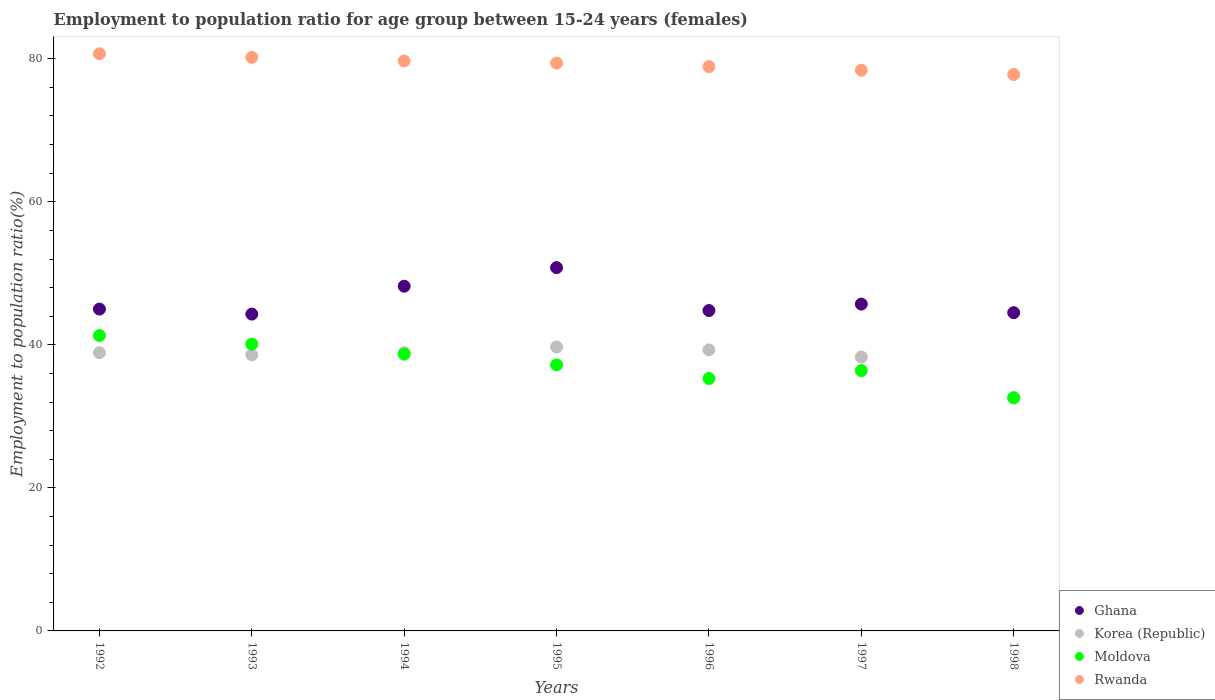How many different coloured dotlines are there?
Keep it short and to the point. 4. Is the number of dotlines equal to the number of legend labels?
Provide a succinct answer. Yes. What is the employment to population ratio in Rwanda in 1997?
Offer a terse response. 78.4. Across all years, what is the maximum employment to population ratio in Korea (Republic)?
Offer a very short reply. 39.7. Across all years, what is the minimum employment to population ratio in Ghana?
Make the answer very short. 44.3. In which year was the employment to population ratio in Moldova maximum?
Offer a very short reply. 1992. In which year was the employment to population ratio in Korea (Republic) minimum?
Provide a short and direct response. 1998. What is the total employment to population ratio in Rwanda in the graph?
Offer a very short reply. 555.1. What is the difference between the employment to population ratio in Rwanda in 1995 and that in 1998?
Make the answer very short. 1.6. What is the difference between the employment to population ratio in Korea (Republic) in 1993 and the employment to population ratio in Rwanda in 1995?
Provide a short and direct response. -40.8. What is the average employment to population ratio in Rwanda per year?
Provide a short and direct response. 79.3. In the year 1992, what is the difference between the employment to population ratio in Moldova and employment to population ratio in Rwanda?
Make the answer very short. -39.4. What is the ratio of the employment to population ratio in Korea (Republic) in 1992 to that in 1994?
Provide a short and direct response. 1. Is the employment to population ratio in Moldova in 1992 less than that in 1993?
Offer a terse response. No. What is the difference between the highest and the second highest employment to population ratio in Rwanda?
Offer a very short reply. 0.5. What is the difference between the highest and the lowest employment to population ratio in Korea (Republic)?
Provide a short and direct response. 7.1. In how many years, is the employment to population ratio in Moldova greater than the average employment to population ratio in Moldova taken over all years?
Provide a succinct answer. 3. Is the sum of the employment to population ratio in Ghana in 1993 and 1995 greater than the maximum employment to population ratio in Moldova across all years?
Provide a succinct answer. Yes. Is it the case that in every year, the sum of the employment to population ratio in Ghana and employment to population ratio in Korea (Republic)  is greater than the employment to population ratio in Moldova?
Give a very brief answer. Yes. Does the employment to population ratio in Korea (Republic) monotonically increase over the years?
Offer a very short reply. No. Is the employment to population ratio in Ghana strictly greater than the employment to population ratio in Moldova over the years?
Your response must be concise. Yes. How many dotlines are there?
Keep it short and to the point. 4. How many years are there in the graph?
Ensure brevity in your answer.  7. What is the difference between two consecutive major ticks on the Y-axis?
Your answer should be compact. 20. Are the values on the major ticks of Y-axis written in scientific E-notation?
Your response must be concise. No. How many legend labels are there?
Offer a very short reply. 4. How are the legend labels stacked?
Your response must be concise. Vertical. What is the title of the graph?
Your response must be concise. Employment to population ratio for age group between 15-24 years (females). What is the label or title of the X-axis?
Keep it short and to the point. Years. What is the Employment to population ratio(%) of Korea (Republic) in 1992?
Your response must be concise. 38.9. What is the Employment to population ratio(%) of Moldova in 1992?
Keep it short and to the point. 41.3. What is the Employment to population ratio(%) in Rwanda in 1992?
Give a very brief answer. 80.7. What is the Employment to population ratio(%) in Ghana in 1993?
Your response must be concise. 44.3. What is the Employment to population ratio(%) in Korea (Republic) in 1993?
Provide a short and direct response. 38.6. What is the Employment to population ratio(%) of Moldova in 1993?
Give a very brief answer. 40.1. What is the Employment to population ratio(%) in Rwanda in 1993?
Offer a terse response. 80.2. What is the Employment to population ratio(%) in Ghana in 1994?
Keep it short and to the point. 48.2. What is the Employment to population ratio(%) of Korea (Republic) in 1994?
Offer a very short reply. 38.9. What is the Employment to population ratio(%) of Moldova in 1994?
Offer a terse response. 38.7. What is the Employment to population ratio(%) in Rwanda in 1994?
Offer a terse response. 79.7. What is the Employment to population ratio(%) in Ghana in 1995?
Your response must be concise. 50.8. What is the Employment to population ratio(%) of Korea (Republic) in 1995?
Make the answer very short. 39.7. What is the Employment to population ratio(%) of Moldova in 1995?
Provide a succinct answer. 37.2. What is the Employment to population ratio(%) in Rwanda in 1995?
Give a very brief answer. 79.4. What is the Employment to population ratio(%) of Ghana in 1996?
Make the answer very short. 44.8. What is the Employment to population ratio(%) in Korea (Republic) in 1996?
Your response must be concise. 39.3. What is the Employment to population ratio(%) of Moldova in 1996?
Make the answer very short. 35.3. What is the Employment to population ratio(%) in Rwanda in 1996?
Offer a very short reply. 78.9. What is the Employment to population ratio(%) of Ghana in 1997?
Your response must be concise. 45.7. What is the Employment to population ratio(%) in Korea (Republic) in 1997?
Offer a very short reply. 38.3. What is the Employment to population ratio(%) in Moldova in 1997?
Provide a succinct answer. 36.4. What is the Employment to population ratio(%) in Rwanda in 1997?
Your answer should be compact. 78.4. What is the Employment to population ratio(%) of Ghana in 1998?
Give a very brief answer. 44.5. What is the Employment to population ratio(%) of Korea (Republic) in 1998?
Keep it short and to the point. 32.6. What is the Employment to population ratio(%) in Moldova in 1998?
Your response must be concise. 32.6. What is the Employment to population ratio(%) in Rwanda in 1998?
Give a very brief answer. 77.8. Across all years, what is the maximum Employment to population ratio(%) of Ghana?
Make the answer very short. 50.8. Across all years, what is the maximum Employment to population ratio(%) in Korea (Republic)?
Offer a very short reply. 39.7. Across all years, what is the maximum Employment to population ratio(%) of Moldova?
Offer a very short reply. 41.3. Across all years, what is the maximum Employment to population ratio(%) in Rwanda?
Ensure brevity in your answer.  80.7. Across all years, what is the minimum Employment to population ratio(%) of Ghana?
Your answer should be very brief. 44.3. Across all years, what is the minimum Employment to population ratio(%) in Korea (Republic)?
Offer a very short reply. 32.6. Across all years, what is the minimum Employment to population ratio(%) in Moldova?
Give a very brief answer. 32.6. Across all years, what is the minimum Employment to population ratio(%) of Rwanda?
Provide a short and direct response. 77.8. What is the total Employment to population ratio(%) in Ghana in the graph?
Make the answer very short. 323.3. What is the total Employment to population ratio(%) in Korea (Republic) in the graph?
Offer a terse response. 266.3. What is the total Employment to population ratio(%) in Moldova in the graph?
Your answer should be very brief. 261.6. What is the total Employment to population ratio(%) in Rwanda in the graph?
Keep it short and to the point. 555.1. What is the difference between the Employment to population ratio(%) of Rwanda in 1992 and that in 1993?
Give a very brief answer. 0.5. What is the difference between the Employment to population ratio(%) in Ghana in 1992 and that in 1994?
Make the answer very short. -3.2. What is the difference between the Employment to population ratio(%) of Rwanda in 1992 and that in 1994?
Your answer should be compact. 1. What is the difference between the Employment to population ratio(%) in Korea (Republic) in 1992 and that in 1995?
Your response must be concise. -0.8. What is the difference between the Employment to population ratio(%) of Ghana in 1992 and that in 1996?
Keep it short and to the point. 0.2. What is the difference between the Employment to population ratio(%) of Korea (Republic) in 1992 and that in 1996?
Your answer should be compact. -0.4. What is the difference between the Employment to population ratio(%) of Moldova in 1992 and that in 1997?
Your answer should be compact. 4.9. What is the difference between the Employment to population ratio(%) of Rwanda in 1992 and that in 1997?
Offer a very short reply. 2.3. What is the difference between the Employment to population ratio(%) of Korea (Republic) in 1992 and that in 1998?
Offer a very short reply. 6.3. What is the difference between the Employment to population ratio(%) of Rwanda in 1992 and that in 1998?
Provide a succinct answer. 2.9. What is the difference between the Employment to population ratio(%) of Ghana in 1993 and that in 1994?
Give a very brief answer. -3.9. What is the difference between the Employment to population ratio(%) of Moldova in 1993 and that in 1994?
Ensure brevity in your answer.  1.4. What is the difference between the Employment to population ratio(%) of Rwanda in 1993 and that in 1994?
Offer a very short reply. 0.5. What is the difference between the Employment to population ratio(%) of Korea (Republic) in 1993 and that in 1995?
Make the answer very short. -1.1. What is the difference between the Employment to population ratio(%) of Moldova in 1993 and that in 1995?
Offer a very short reply. 2.9. What is the difference between the Employment to population ratio(%) in Rwanda in 1993 and that in 1995?
Offer a very short reply. 0.8. What is the difference between the Employment to population ratio(%) in Moldova in 1993 and that in 1996?
Give a very brief answer. 4.8. What is the difference between the Employment to population ratio(%) of Moldova in 1993 and that in 1997?
Offer a very short reply. 3.7. What is the difference between the Employment to population ratio(%) of Rwanda in 1993 and that in 1997?
Make the answer very short. 1.8. What is the difference between the Employment to population ratio(%) in Ghana in 1993 and that in 1998?
Ensure brevity in your answer.  -0.2. What is the difference between the Employment to population ratio(%) of Rwanda in 1993 and that in 1998?
Offer a very short reply. 2.4. What is the difference between the Employment to population ratio(%) in Ghana in 1994 and that in 1995?
Give a very brief answer. -2.6. What is the difference between the Employment to population ratio(%) of Korea (Republic) in 1994 and that in 1995?
Offer a terse response. -0.8. What is the difference between the Employment to population ratio(%) in Rwanda in 1994 and that in 1995?
Ensure brevity in your answer.  0.3. What is the difference between the Employment to population ratio(%) of Ghana in 1994 and that in 1996?
Provide a succinct answer. 3.4. What is the difference between the Employment to population ratio(%) in Korea (Republic) in 1994 and that in 1996?
Provide a short and direct response. -0.4. What is the difference between the Employment to population ratio(%) in Moldova in 1994 and that in 1996?
Offer a terse response. 3.4. What is the difference between the Employment to population ratio(%) of Ghana in 1994 and that in 1997?
Give a very brief answer. 2.5. What is the difference between the Employment to population ratio(%) in Moldova in 1994 and that in 1997?
Provide a short and direct response. 2.3. What is the difference between the Employment to population ratio(%) of Korea (Republic) in 1994 and that in 1998?
Provide a short and direct response. 6.3. What is the difference between the Employment to population ratio(%) in Rwanda in 1994 and that in 1998?
Make the answer very short. 1.9. What is the difference between the Employment to population ratio(%) in Ghana in 1995 and that in 1996?
Keep it short and to the point. 6. What is the difference between the Employment to population ratio(%) of Korea (Republic) in 1995 and that in 1996?
Provide a succinct answer. 0.4. What is the difference between the Employment to population ratio(%) of Moldova in 1995 and that in 1996?
Your answer should be compact. 1.9. What is the difference between the Employment to population ratio(%) in Korea (Republic) in 1995 and that in 1997?
Offer a terse response. 1.4. What is the difference between the Employment to population ratio(%) in Moldova in 1995 and that in 1997?
Make the answer very short. 0.8. What is the difference between the Employment to population ratio(%) in Moldova in 1995 and that in 1998?
Your answer should be compact. 4.6. What is the difference between the Employment to population ratio(%) of Korea (Republic) in 1996 and that in 1997?
Ensure brevity in your answer.  1. What is the difference between the Employment to population ratio(%) in Rwanda in 1996 and that in 1997?
Offer a terse response. 0.5. What is the difference between the Employment to population ratio(%) in Moldova in 1996 and that in 1998?
Provide a succinct answer. 2.7. What is the difference between the Employment to population ratio(%) of Rwanda in 1996 and that in 1998?
Provide a short and direct response. 1.1. What is the difference between the Employment to population ratio(%) in Ghana in 1997 and that in 1998?
Make the answer very short. 1.2. What is the difference between the Employment to population ratio(%) of Korea (Republic) in 1997 and that in 1998?
Your answer should be very brief. 5.7. What is the difference between the Employment to population ratio(%) in Rwanda in 1997 and that in 1998?
Your answer should be very brief. 0.6. What is the difference between the Employment to population ratio(%) of Ghana in 1992 and the Employment to population ratio(%) of Moldova in 1993?
Give a very brief answer. 4.9. What is the difference between the Employment to population ratio(%) of Ghana in 1992 and the Employment to population ratio(%) of Rwanda in 1993?
Make the answer very short. -35.2. What is the difference between the Employment to population ratio(%) of Korea (Republic) in 1992 and the Employment to population ratio(%) of Rwanda in 1993?
Your answer should be very brief. -41.3. What is the difference between the Employment to population ratio(%) in Moldova in 1992 and the Employment to population ratio(%) in Rwanda in 1993?
Ensure brevity in your answer.  -38.9. What is the difference between the Employment to population ratio(%) in Ghana in 1992 and the Employment to population ratio(%) in Korea (Republic) in 1994?
Offer a very short reply. 6.1. What is the difference between the Employment to population ratio(%) of Ghana in 1992 and the Employment to population ratio(%) of Moldova in 1994?
Your answer should be compact. 6.3. What is the difference between the Employment to population ratio(%) in Ghana in 1992 and the Employment to population ratio(%) in Rwanda in 1994?
Keep it short and to the point. -34.7. What is the difference between the Employment to population ratio(%) of Korea (Republic) in 1992 and the Employment to population ratio(%) of Moldova in 1994?
Your response must be concise. 0.2. What is the difference between the Employment to population ratio(%) of Korea (Republic) in 1992 and the Employment to population ratio(%) of Rwanda in 1994?
Provide a succinct answer. -40.8. What is the difference between the Employment to population ratio(%) of Moldova in 1992 and the Employment to population ratio(%) of Rwanda in 1994?
Make the answer very short. -38.4. What is the difference between the Employment to population ratio(%) in Ghana in 1992 and the Employment to population ratio(%) in Korea (Republic) in 1995?
Give a very brief answer. 5.3. What is the difference between the Employment to population ratio(%) of Ghana in 1992 and the Employment to population ratio(%) of Rwanda in 1995?
Provide a succinct answer. -34.4. What is the difference between the Employment to population ratio(%) in Korea (Republic) in 1992 and the Employment to population ratio(%) in Rwanda in 1995?
Your answer should be very brief. -40.5. What is the difference between the Employment to population ratio(%) of Moldova in 1992 and the Employment to population ratio(%) of Rwanda in 1995?
Provide a succinct answer. -38.1. What is the difference between the Employment to population ratio(%) in Ghana in 1992 and the Employment to population ratio(%) in Korea (Republic) in 1996?
Offer a terse response. 5.7. What is the difference between the Employment to population ratio(%) in Ghana in 1992 and the Employment to population ratio(%) in Rwanda in 1996?
Your answer should be compact. -33.9. What is the difference between the Employment to population ratio(%) of Korea (Republic) in 1992 and the Employment to population ratio(%) of Moldova in 1996?
Your answer should be compact. 3.6. What is the difference between the Employment to population ratio(%) in Korea (Republic) in 1992 and the Employment to population ratio(%) in Rwanda in 1996?
Provide a succinct answer. -40. What is the difference between the Employment to population ratio(%) of Moldova in 1992 and the Employment to population ratio(%) of Rwanda in 1996?
Your response must be concise. -37.6. What is the difference between the Employment to population ratio(%) of Ghana in 1992 and the Employment to population ratio(%) of Korea (Republic) in 1997?
Provide a succinct answer. 6.7. What is the difference between the Employment to population ratio(%) in Ghana in 1992 and the Employment to population ratio(%) in Moldova in 1997?
Your answer should be compact. 8.6. What is the difference between the Employment to population ratio(%) in Ghana in 1992 and the Employment to population ratio(%) in Rwanda in 1997?
Your answer should be compact. -33.4. What is the difference between the Employment to population ratio(%) in Korea (Republic) in 1992 and the Employment to population ratio(%) in Moldova in 1997?
Provide a short and direct response. 2.5. What is the difference between the Employment to population ratio(%) in Korea (Republic) in 1992 and the Employment to population ratio(%) in Rwanda in 1997?
Keep it short and to the point. -39.5. What is the difference between the Employment to population ratio(%) of Moldova in 1992 and the Employment to population ratio(%) of Rwanda in 1997?
Offer a terse response. -37.1. What is the difference between the Employment to population ratio(%) of Ghana in 1992 and the Employment to population ratio(%) of Korea (Republic) in 1998?
Ensure brevity in your answer.  12.4. What is the difference between the Employment to population ratio(%) in Ghana in 1992 and the Employment to population ratio(%) in Moldova in 1998?
Offer a terse response. 12.4. What is the difference between the Employment to population ratio(%) of Ghana in 1992 and the Employment to population ratio(%) of Rwanda in 1998?
Make the answer very short. -32.8. What is the difference between the Employment to population ratio(%) of Korea (Republic) in 1992 and the Employment to population ratio(%) of Rwanda in 1998?
Give a very brief answer. -38.9. What is the difference between the Employment to population ratio(%) of Moldova in 1992 and the Employment to population ratio(%) of Rwanda in 1998?
Your answer should be very brief. -36.5. What is the difference between the Employment to population ratio(%) in Ghana in 1993 and the Employment to population ratio(%) in Moldova in 1994?
Provide a short and direct response. 5.6. What is the difference between the Employment to population ratio(%) of Ghana in 1993 and the Employment to population ratio(%) of Rwanda in 1994?
Keep it short and to the point. -35.4. What is the difference between the Employment to population ratio(%) in Korea (Republic) in 1993 and the Employment to population ratio(%) in Moldova in 1994?
Offer a terse response. -0.1. What is the difference between the Employment to population ratio(%) of Korea (Republic) in 1993 and the Employment to population ratio(%) of Rwanda in 1994?
Ensure brevity in your answer.  -41.1. What is the difference between the Employment to population ratio(%) of Moldova in 1993 and the Employment to population ratio(%) of Rwanda in 1994?
Make the answer very short. -39.6. What is the difference between the Employment to population ratio(%) of Ghana in 1993 and the Employment to population ratio(%) of Korea (Republic) in 1995?
Give a very brief answer. 4.6. What is the difference between the Employment to population ratio(%) in Ghana in 1993 and the Employment to population ratio(%) in Rwanda in 1995?
Ensure brevity in your answer.  -35.1. What is the difference between the Employment to population ratio(%) of Korea (Republic) in 1993 and the Employment to population ratio(%) of Rwanda in 1995?
Offer a very short reply. -40.8. What is the difference between the Employment to population ratio(%) of Moldova in 1993 and the Employment to population ratio(%) of Rwanda in 1995?
Provide a short and direct response. -39.3. What is the difference between the Employment to population ratio(%) in Ghana in 1993 and the Employment to population ratio(%) in Moldova in 1996?
Your answer should be compact. 9. What is the difference between the Employment to population ratio(%) in Ghana in 1993 and the Employment to population ratio(%) in Rwanda in 1996?
Offer a very short reply. -34.6. What is the difference between the Employment to population ratio(%) in Korea (Republic) in 1993 and the Employment to population ratio(%) in Rwanda in 1996?
Make the answer very short. -40.3. What is the difference between the Employment to population ratio(%) of Moldova in 1993 and the Employment to population ratio(%) of Rwanda in 1996?
Provide a short and direct response. -38.8. What is the difference between the Employment to population ratio(%) in Ghana in 1993 and the Employment to population ratio(%) in Korea (Republic) in 1997?
Keep it short and to the point. 6. What is the difference between the Employment to population ratio(%) in Ghana in 1993 and the Employment to population ratio(%) in Rwanda in 1997?
Make the answer very short. -34.1. What is the difference between the Employment to population ratio(%) of Korea (Republic) in 1993 and the Employment to population ratio(%) of Moldova in 1997?
Provide a succinct answer. 2.2. What is the difference between the Employment to population ratio(%) of Korea (Republic) in 1993 and the Employment to population ratio(%) of Rwanda in 1997?
Your answer should be compact. -39.8. What is the difference between the Employment to population ratio(%) in Moldova in 1993 and the Employment to population ratio(%) in Rwanda in 1997?
Ensure brevity in your answer.  -38.3. What is the difference between the Employment to population ratio(%) of Ghana in 1993 and the Employment to population ratio(%) of Korea (Republic) in 1998?
Keep it short and to the point. 11.7. What is the difference between the Employment to population ratio(%) of Ghana in 1993 and the Employment to population ratio(%) of Moldova in 1998?
Give a very brief answer. 11.7. What is the difference between the Employment to population ratio(%) in Ghana in 1993 and the Employment to population ratio(%) in Rwanda in 1998?
Keep it short and to the point. -33.5. What is the difference between the Employment to population ratio(%) of Korea (Republic) in 1993 and the Employment to population ratio(%) of Rwanda in 1998?
Offer a very short reply. -39.2. What is the difference between the Employment to population ratio(%) in Moldova in 1993 and the Employment to population ratio(%) in Rwanda in 1998?
Keep it short and to the point. -37.7. What is the difference between the Employment to population ratio(%) of Ghana in 1994 and the Employment to population ratio(%) of Korea (Republic) in 1995?
Offer a terse response. 8.5. What is the difference between the Employment to population ratio(%) of Ghana in 1994 and the Employment to population ratio(%) of Moldova in 1995?
Offer a terse response. 11. What is the difference between the Employment to population ratio(%) of Ghana in 1994 and the Employment to population ratio(%) of Rwanda in 1995?
Give a very brief answer. -31.2. What is the difference between the Employment to population ratio(%) in Korea (Republic) in 1994 and the Employment to population ratio(%) in Moldova in 1995?
Your answer should be compact. 1.7. What is the difference between the Employment to population ratio(%) of Korea (Republic) in 1994 and the Employment to population ratio(%) of Rwanda in 1995?
Ensure brevity in your answer.  -40.5. What is the difference between the Employment to population ratio(%) in Moldova in 1994 and the Employment to population ratio(%) in Rwanda in 1995?
Give a very brief answer. -40.7. What is the difference between the Employment to population ratio(%) of Ghana in 1994 and the Employment to population ratio(%) of Korea (Republic) in 1996?
Make the answer very short. 8.9. What is the difference between the Employment to population ratio(%) in Ghana in 1994 and the Employment to population ratio(%) in Moldova in 1996?
Your response must be concise. 12.9. What is the difference between the Employment to population ratio(%) of Ghana in 1994 and the Employment to population ratio(%) of Rwanda in 1996?
Your response must be concise. -30.7. What is the difference between the Employment to population ratio(%) of Korea (Republic) in 1994 and the Employment to population ratio(%) of Moldova in 1996?
Your answer should be compact. 3.6. What is the difference between the Employment to population ratio(%) of Korea (Republic) in 1994 and the Employment to population ratio(%) of Rwanda in 1996?
Give a very brief answer. -40. What is the difference between the Employment to population ratio(%) in Moldova in 1994 and the Employment to population ratio(%) in Rwanda in 1996?
Your answer should be very brief. -40.2. What is the difference between the Employment to population ratio(%) of Ghana in 1994 and the Employment to population ratio(%) of Moldova in 1997?
Make the answer very short. 11.8. What is the difference between the Employment to population ratio(%) of Ghana in 1994 and the Employment to population ratio(%) of Rwanda in 1997?
Provide a succinct answer. -30.2. What is the difference between the Employment to population ratio(%) in Korea (Republic) in 1994 and the Employment to population ratio(%) in Rwanda in 1997?
Keep it short and to the point. -39.5. What is the difference between the Employment to population ratio(%) in Moldova in 1994 and the Employment to population ratio(%) in Rwanda in 1997?
Your response must be concise. -39.7. What is the difference between the Employment to population ratio(%) of Ghana in 1994 and the Employment to population ratio(%) of Korea (Republic) in 1998?
Your answer should be very brief. 15.6. What is the difference between the Employment to population ratio(%) of Ghana in 1994 and the Employment to population ratio(%) of Moldova in 1998?
Offer a very short reply. 15.6. What is the difference between the Employment to population ratio(%) of Ghana in 1994 and the Employment to population ratio(%) of Rwanda in 1998?
Offer a very short reply. -29.6. What is the difference between the Employment to population ratio(%) in Korea (Republic) in 1994 and the Employment to population ratio(%) in Rwanda in 1998?
Provide a succinct answer. -38.9. What is the difference between the Employment to population ratio(%) in Moldova in 1994 and the Employment to population ratio(%) in Rwanda in 1998?
Offer a terse response. -39.1. What is the difference between the Employment to population ratio(%) of Ghana in 1995 and the Employment to population ratio(%) of Rwanda in 1996?
Provide a succinct answer. -28.1. What is the difference between the Employment to population ratio(%) of Korea (Republic) in 1995 and the Employment to population ratio(%) of Rwanda in 1996?
Give a very brief answer. -39.2. What is the difference between the Employment to population ratio(%) in Moldova in 1995 and the Employment to population ratio(%) in Rwanda in 1996?
Make the answer very short. -41.7. What is the difference between the Employment to population ratio(%) of Ghana in 1995 and the Employment to population ratio(%) of Rwanda in 1997?
Provide a succinct answer. -27.6. What is the difference between the Employment to population ratio(%) of Korea (Republic) in 1995 and the Employment to population ratio(%) of Moldova in 1997?
Offer a terse response. 3.3. What is the difference between the Employment to population ratio(%) in Korea (Republic) in 1995 and the Employment to population ratio(%) in Rwanda in 1997?
Your answer should be compact. -38.7. What is the difference between the Employment to population ratio(%) of Moldova in 1995 and the Employment to population ratio(%) of Rwanda in 1997?
Offer a very short reply. -41.2. What is the difference between the Employment to population ratio(%) in Ghana in 1995 and the Employment to population ratio(%) in Moldova in 1998?
Your answer should be compact. 18.2. What is the difference between the Employment to population ratio(%) in Korea (Republic) in 1995 and the Employment to population ratio(%) in Moldova in 1998?
Your response must be concise. 7.1. What is the difference between the Employment to population ratio(%) of Korea (Republic) in 1995 and the Employment to population ratio(%) of Rwanda in 1998?
Offer a terse response. -38.1. What is the difference between the Employment to population ratio(%) in Moldova in 1995 and the Employment to population ratio(%) in Rwanda in 1998?
Provide a short and direct response. -40.6. What is the difference between the Employment to population ratio(%) of Ghana in 1996 and the Employment to population ratio(%) of Rwanda in 1997?
Keep it short and to the point. -33.6. What is the difference between the Employment to population ratio(%) in Korea (Republic) in 1996 and the Employment to population ratio(%) in Moldova in 1997?
Give a very brief answer. 2.9. What is the difference between the Employment to population ratio(%) in Korea (Republic) in 1996 and the Employment to population ratio(%) in Rwanda in 1997?
Provide a short and direct response. -39.1. What is the difference between the Employment to population ratio(%) of Moldova in 1996 and the Employment to population ratio(%) of Rwanda in 1997?
Your response must be concise. -43.1. What is the difference between the Employment to population ratio(%) of Ghana in 1996 and the Employment to population ratio(%) of Moldova in 1998?
Your answer should be compact. 12.2. What is the difference between the Employment to population ratio(%) of Ghana in 1996 and the Employment to population ratio(%) of Rwanda in 1998?
Ensure brevity in your answer.  -33. What is the difference between the Employment to population ratio(%) of Korea (Republic) in 1996 and the Employment to population ratio(%) of Rwanda in 1998?
Offer a very short reply. -38.5. What is the difference between the Employment to population ratio(%) in Moldova in 1996 and the Employment to population ratio(%) in Rwanda in 1998?
Give a very brief answer. -42.5. What is the difference between the Employment to population ratio(%) of Ghana in 1997 and the Employment to population ratio(%) of Korea (Republic) in 1998?
Provide a short and direct response. 13.1. What is the difference between the Employment to population ratio(%) in Ghana in 1997 and the Employment to population ratio(%) in Rwanda in 1998?
Provide a short and direct response. -32.1. What is the difference between the Employment to population ratio(%) of Korea (Republic) in 1997 and the Employment to population ratio(%) of Rwanda in 1998?
Your response must be concise. -39.5. What is the difference between the Employment to population ratio(%) in Moldova in 1997 and the Employment to population ratio(%) in Rwanda in 1998?
Offer a terse response. -41.4. What is the average Employment to population ratio(%) of Ghana per year?
Your answer should be very brief. 46.19. What is the average Employment to population ratio(%) of Korea (Republic) per year?
Keep it short and to the point. 38.04. What is the average Employment to population ratio(%) in Moldova per year?
Your answer should be compact. 37.37. What is the average Employment to population ratio(%) in Rwanda per year?
Your answer should be compact. 79.3. In the year 1992, what is the difference between the Employment to population ratio(%) of Ghana and Employment to population ratio(%) of Rwanda?
Ensure brevity in your answer.  -35.7. In the year 1992, what is the difference between the Employment to population ratio(%) in Korea (Republic) and Employment to population ratio(%) in Rwanda?
Your answer should be very brief. -41.8. In the year 1992, what is the difference between the Employment to population ratio(%) in Moldova and Employment to population ratio(%) in Rwanda?
Offer a terse response. -39.4. In the year 1993, what is the difference between the Employment to population ratio(%) in Ghana and Employment to population ratio(%) in Korea (Republic)?
Your response must be concise. 5.7. In the year 1993, what is the difference between the Employment to population ratio(%) of Ghana and Employment to population ratio(%) of Rwanda?
Make the answer very short. -35.9. In the year 1993, what is the difference between the Employment to population ratio(%) of Korea (Republic) and Employment to population ratio(%) of Rwanda?
Offer a terse response. -41.6. In the year 1993, what is the difference between the Employment to population ratio(%) of Moldova and Employment to population ratio(%) of Rwanda?
Make the answer very short. -40.1. In the year 1994, what is the difference between the Employment to population ratio(%) in Ghana and Employment to population ratio(%) in Rwanda?
Offer a very short reply. -31.5. In the year 1994, what is the difference between the Employment to population ratio(%) in Korea (Republic) and Employment to population ratio(%) in Rwanda?
Offer a very short reply. -40.8. In the year 1994, what is the difference between the Employment to population ratio(%) in Moldova and Employment to population ratio(%) in Rwanda?
Provide a short and direct response. -41. In the year 1995, what is the difference between the Employment to population ratio(%) in Ghana and Employment to population ratio(%) in Korea (Republic)?
Offer a very short reply. 11.1. In the year 1995, what is the difference between the Employment to population ratio(%) of Ghana and Employment to population ratio(%) of Rwanda?
Ensure brevity in your answer.  -28.6. In the year 1995, what is the difference between the Employment to population ratio(%) in Korea (Republic) and Employment to population ratio(%) in Rwanda?
Ensure brevity in your answer.  -39.7. In the year 1995, what is the difference between the Employment to population ratio(%) in Moldova and Employment to population ratio(%) in Rwanda?
Keep it short and to the point. -42.2. In the year 1996, what is the difference between the Employment to population ratio(%) in Ghana and Employment to population ratio(%) in Rwanda?
Ensure brevity in your answer.  -34.1. In the year 1996, what is the difference between the Employment to population ratio(%) in Korea (Republic) and Employment to population ratio(%) in Rwanda?
Keep it short and to the point. -39.6. In the year 1996, what is the difference between the Employment to population ratio(%) in Moldova and Employment to population ratio(%) in Rwanda?
Keep it short and to the point. -43.6. In the year 1997, what is the difference between the Employment to population ratio(%) in Ghana and Employment to population ratio(%) in Korea (Republic)?
Offer a very short reply. 7.4. In the year 1997, what is the difference between the Employment to population ratio(%) of Ghana and Employment to population ratio(%) of Moldova?
Your answer should be very brief. 9.3. In the year 1997, what is the difference between the Employment to population ratio(%) of Ghana and Employment to population ratio(%) of Rwanda?
Your answer should be compact. -32.7. In the year 1997, what is the difference between the Employment to population ratio(%) of Korea (Republic) and Employment to population ratio(%) of Moldova?
Your response must be concise. 1.9. In the year 1997, what is the difference between the Employment to population ratio(%) in Korea (Republic) and Employment to population ratio(%) in Rwanda?
Ensure brevity in your answer.  -40.1. In the year 1997, what is the difference between the Employment to population ratio(%) in Moldova and Employment to population ratio(%) in Rwanda?
Provide a succinct answer. -42. In the year 1998, what is the difference between the Employment to population ratio(%) of Ghana and Employment to population ratio(%) of Moldova?
Give a very brief answer. 11.9. In the year 1998, what is the difference between the Employment to population ratio(%) in Ghana and Employment to population ratio(%) in Rwanda?
Ensure brevity in your answer.  -33.3. In the year 1998, what is the difference between the Employment to population ratio(%) in Korea (Republic) and Employment to population ratio(%) in Moldova?
Make the answer very short. 0. In the year 1998, what is the difference between the Employment to population ratio(%) in Korea (Republic) and Employment to population ratio(%) in Rwanda?
Your response must be concise. -45.2. In the year 1998, what is the difference between the Employment to population ratio(%) of Moldova and Employment to population ratio(%) of Rwanda?
Your response must be concise. -45.2. What is the ratio of the Employment to population ratio(%) in Ghana in 1992 to that in 1993?
Your answer should be compact. 1.02. What is the ratio of the Employment to population ratio(%) of Moldova in 1992 to that in 1993?
Ensure brevity in your answer.  1.03. What is the ratio of the Employment to population ratio(%) in Ghana in 1992 to that in 1994?
Offer a very short reply. 0.93. What is the ratio of the Employment to population ratio(%) of Moldova in 1992 to that in 1994?
Ensure brevity in your answer.  1.07. What is the ratio of the Employment to population ratio(%) in Rwanda in 1992 to that in 1994?
Ensure brevity in your answer.  1.01. What is the ratio of the Employment to population ratio(%) of Ghana in 1992 to that in 1995?
Provide a succinct answer. 0.89. What is the ratio of the Employment to population ratio(%) of Korea (Republic) in 1992 to that in 1995?
Ensure brevity in your answer.  0.98. What is the ratio of the Employment to population ratio(%) of Moldova in 1992 to that in 1995?
Your answer should be very brief. 1.11. What is the ratio of the Employment to population ratio(%) of Rwanda in 1992 to that in 1995?
Give a very brief answer. 1.02. What is the ratio of the Employment to population ratio(%) in Korea (Republic) in 1992 to that in 1996?
Offer a very short reply. 0.99. What is the ratio of the Employment to population ratio(%) of Moldova in 1992 to that in 1996?
Your answer should be very brief. 1.17. What is the ratio of the Employment to population ratio(%) of Rwanda in 1992 to that in 1996?
Your answer should be very brief. 1.02. What is the ratio of the Employment to population ratio(%) in Ghana in 1992 to that in 1997?
Make the answer very short. 0.98. What is the ratio of the Employment to population ratio(%) of Korea (Republic) in 1992 to that in 1997?
Ensure brevity in your answer.  1.02. What is the ratio of the Employment to population ratio(%) in Moldova in 1992 to that in 1997?
Your answer should be very brief. 1.13. What is the ratio of the Employment to population ratio(%) in Rwanda in 1992 to that in 1997?
Keep it short and to the point. 1.03. What is the ratio of the Employment to population ratio(%) in Ghana in 1992 to that in 1998?
Offer a terse response. 1.01. What is the ratio of the Employment to population ratio(%) of Korea (Republic) in 1992 to that in 1998?
Your response must be concise. 1.19. What is the ratio of the Employment to population ratio(%) of Moldova in 1992 to that in 1998?
Provide a succinct answer. 1.27. What is the ratio of the Employment to population ratio(%) in Rwanda in 1992 to that in 1998?
Provide a short and direct response. 1.04. What is the ratio of the Employment to population ratio(%) in Ghana in 1993 to that in 1994?
Ensure brevity in your answer.  0.92. What is the ratio of the Employment to population ratio(%) in Korea (Republic) in 1993 to that in 1994?
Provide a succinct answer. 0.99. What is the ratio of the Employment to population ratio(%) in Moldova in 1993 to that in 1994?
Give a very brief answer. 1.04. What is the ratio of the Employment to population ratio(%) of Ghana in 1993 to that in 1995?
Your answer should be very brief. 0.87. What is the ratio of the Employment to population ratio(%) of Korea (Republic) in 1993 to that in 1995?
Ensure brevity in your answer.  0.97. What is the ratio of the Employment to population ratio(%) in Moldova in 1993 to that in 1995?
Offer a terse response. 1.08. What is the ratio of the Employment to population ratio(%) of Ghana in 1993 to that in 1996?
Give a very brief answer. 0.99. What is the ratio of the Employment to population ratio(%) in Korea (Republic) in 1993 to that in 1996?
Your answer should be very brief. 0.98. What is the ratio of the Employment to population ratio(%) of Moldova in 1993 to that in 1996?
Provide a succinct answer. 1.14. What is the ratio of the Employment to population ratio(%) in Rwanda in 1993 to that in 1996?
Offer a very short reply. 1.02. What is the ratio of the Employment to population ratio(%) in Ghana in 1993 to that in 1997?
Offer a terse response. 0.97. What is the ratio of the Employment to population ratio(%) in Moldova in 1993 to that in 1997?
Your response must be concise. 1.1. What is the ratio of the Employment to population ratio(%) of Rwanda in 1993 to that in 1997?
Your answer should be very brief. 1.02. What is the ratio of the Employment to population ratio(%) in Korea (Republic) in 1993 to that in 1998?
Make the answer very short. 1.18. What is the ratio of the Employment to population ratio(%) of Moldova in 1993 to that in 1998?
Make the answer very short. 1.23. What is the ratio of the Employment to population ratio(%) of Rwanda in 1993 to that in 1998?
Your answer should be compact. 1.03. What is the ratio of the Employment to population ratio(%) of Ghana in 1994 to that in 1995?
Give a very brief answer. 0.95. What is the ratio of the Employment to population ratio(%) in Korea (Republic) in 1994 to that in 1995?
Keep it short and to the point. 0.98. What is the ratio of the Employment to population ratio(%) in Moldova in 1994 to that in 1995?
Offer a terse response. 1.04. What is the ratio of the Employment to population ratio(%) of Rwanda in 1994 to that in 1995?
Ensure brevity in your answer.  1. What is the ratio of the Employment to population ratio(%) in Ghana in 1994 to that in 1996?
Your answer should be compact. 1.08. What is the ratio of the Employment to population ratio(%) of Korea (Republic) in 1994 to that in 1996?
Make the answer very short. 0.99. What is the ratio of the Employment to population ratio(%) in Moldova in 1994 to that in 1996?
Ensure brevity in your answer.  1.1. What is the ratio of the Employment to population ratio(%) in Ghana in 1994 to that in 1997?
Give a very brief answer. 1.05. What is the ratio of the Employment to population ratio(%) of Korea (Republic) in 1994 to that in 1997?
Provide a succinct answer. 1.02. What is the ratio of the Employment to population ratio(%) in Moldova in 1994 to that in 1997?
Your response must be concise. 1.06. What is the ratio of the Employment to population ratio(%) in Rwanda in 1994 to that in 1997?
Offer a terse response. 1.02. What is the ratio of the Employment to population ratio(%) of Ghana in 1994 to that in 1998?
Give a very brief answer. 1.08. What is the ratio of the Employment to population ratio(%) in Korea (Republic) in 1994 to that in 1998?
Provide a short and direct response. 1.19. What is the ratio of the Employment to population ratio(%) of Moldova in 1994 to that in 1998?
Ensure brevity in your answer.  1.19. What is the ratio of the Employment to population ratio(%) of Rwanda in 1994 to that in 1998?
Make the answer very short. 1.02. What is the ratio of the Employment to population ratio(%) of Ghana in 1995 to that in 1996?
Offer a very short reply. 1.13. What is the ratio of the Employment to population ratio(%) of Korea (Republic) in 1995 to that in 1996?
Provide a short and direct response. 1.01. What is the ratio of the Employment to population ratio(%) in Moldova in 1995 to that in 1996?
Provide a short and direct response. 1.05. What is the ratio of the Employment to population ratio(%) in Ghana in 1995 to that in 1997?
Keep it short and to the point. 1.11. What is the ratio of the Employment to population ratio(%) of Korea (Republic) in 1995 to that in 1997?
Offer a very short reply. 1.04. What is the ratio of the Employment to population ratio(%) in Moldova in 1995 to that in 1997?
Your response must be concise. 1.02. What is the ratio of the Employment to population ratio(%) in Rwanda in 1995 to that in 1997?
Offer a very short reply. 1.01. What is the ratio of the Employment to population ratio(%) of Ghana in 1995 to that in 1998?
Provide a succinct answer. 1.14. What is the ratio of the Employment to population ratio(%) of Korea (Republic) in 1995 to that in 1998?
Provide a short and direct response. 1.22. What is the ratio of the Employment to population ratio(%) in Moldova in 1995 to that in 1998?
Keep it short and to the point. 1.14. What is the ratio of the Employment to population ratio(%) in Rwanda in 1995 to that in 1998?
Offer a terse response. 1.02. What is the ratio of the Employment to population ratio(%) of Ghana in 1996 to that in 1997?
Give a very brief answer. 0.98. What is the ratio of the Employment to population ratio(%) of Korea (Republic) in 1996 to that in 1997?
Provide a succinct answer. 1.03. What is the ratio of the Employment to population ratio(%) of Moldova in 1996 to that in 1997?
Offer a terse response. 0.97. What is the ratio of the Employment to population ratio(%) in Rwanda in 1996 to that in 1997?
Make the answer very short. 1.01. What is the ratio of the Employment to population ratio(%) of Korea (Republic) in 1996 to that in 1998?
Your response must be concise. 1.21. What is the ratio of the Employment to population ratio(%) of Moldova in 1996 to that in 1998?
Your response must be concise. 1.08. What is the ratio of the Employment to population ratio(%) in Rwanda in 1996 to that in 1998?
Your response must be concise. 1.01. What is the ratio of the Employment to population ratio(%) of Ghana in 1997 to that in 1998?
Keep it short and to the point. 1.03. What is the ratio of the Employment to population ratio(%) of Korea (Republic) in 1997 to that in 1998?
Keep it short and to the point. 1.17. What is the ratio of the Employment to population ratio(%) in Moldova in 1997 to that in 1998?
Your answer should be compact. 1.12. What is the ratio of the Employment to population ratio(%) in Rwanda in 1997 to that in 1998?
Make the answer very short. 1.01. What is the difference between the highest and the second highest Employment to population ratio(%) of Korea (Republic)?
Provide a succinct answer. 0.4. What is the difference between the highest and the second highest Employment to population ratio(%) in Moldova?
Offer a very short reply. 1.2. What is the difference between the highest and the second highest Employment to population ratio(%) of Rwanda?
Provide a succinct answer. 0.5. 